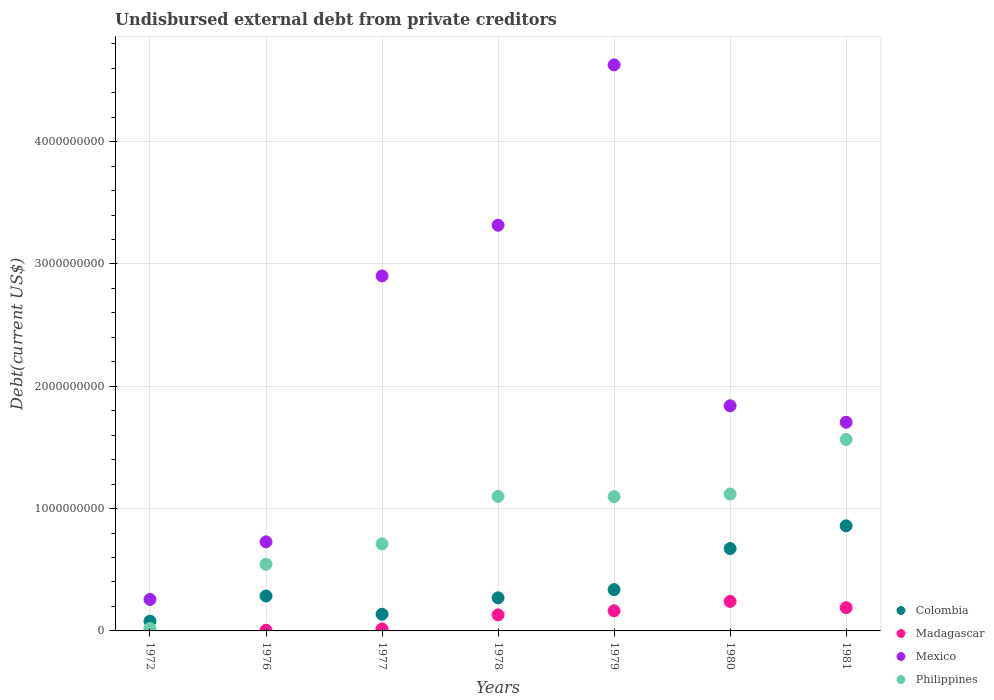What is the total debt in Colombia in 1979?
Make the answer very short. 3.38e+08. Across all years, what is the maximum total debt in Mexico?
Provide a succinct answer. 4.63e+09. Across all years, what is the minimum total debt in Colombia?
Your response must be concise. 7.95e+07. In which year was the total debt in Madagascar maximum?
Provide a short and direct response. 1980. What is the total total debt in Mexico in the graph?
Your answer should be very brief. 1.54e+1. What is the difference between the total debt in Philippines in 1972 and that in 1978?
Offer a terse response. -1.08e+09. What is the difference between the total debt in Philippines in 1978 and the total debt in Colombia in 1977?
Provide a short and direct response. 9.63e+08. What is the average total debt in Colombia per year?
Offer a very short reply. 3.77e+08. In the year 1978, what is the difference between the total debt in Madagascar and total debt in Colombia?
Give a very brief answer. -1.39e+08. In how many years, is the total debt in Mexico greater than 1600000000 US$?
Your response must be concise. 5. What is the ratio of the total debt in Madagascar in 1978 to that in 1981?
Your answer should be very brief. 0.69. Is the total debt in Philippines in 1976 less than that in 1979?
Offer a terse response. Yes. What is the difference between the highest and the second highest total debt in Mexico?
Your answer should be very brief. 1.31e+09. What is the difference between the highest and the lowest total debt in Philippines?
Offer a terse response. 1.55e+09. In how many years, is the total debt in Mexico greater than the average total debt in Mexico taken over all years?
Provide a succinct answer. 3. Is the sum of the total debt in Mexico in 1976 and 1981 greater than the maximum total debt in Colombia across all years?
Offer a very short reply. Yes. Is it the case that in every year, the sum of the total debt in Colombia and total debt in Philippines  is greater than the total debt in Madagascar?
Your answer should be very brief. Yes. Does the total debt in Mexico monotonically increase over the years?
Make the answer very short. No. Is the total debt in Mexico strictly greater than the total debt in Philippines over the years?
Provide a succinct answer. Yes. Does the graph contain grids?
Provide a succinct answer. Yes. How many legend labels are there?
Give a very brief answer. 4. How are the legend labels stacked?
Provide a succinct answer. Vertical. What is the title of the graph?
Ensure brevity in your answer.  Undisbursed external debt from private creditors. Does "St. Vincent and the Grenadines" appear as one of the legend labels in the graph?
Your response must be concise. No. What is the label or title of the X-axis?
Offer a terse response. Years. What is the label or title of the Y-axis?
Offer a terse response. Debt(current US$). What is the Debt(current US$) in Colombia in 1972?
Keep it short and to the point. 7.95e+07. What is the Debt(current US$) in Madagascar in 1972?
Make the answer very short. 1.18e+06. What is the Debt(current US$) in Mexico in 1972?
Provide a succinct answer. 2.57e+08. What is the Debt(current US$) of Philippines in 1972?
Your answer should be compact. 1.99e+07. What is the Debt(current US$) of Colombia in 1976?
Your answer should be compact. 2.85e+08. What is the Debt(current US$) in Madagascar in 1976?
Provide a short and direct response. 5.58e+06. What is the Debt(current US$) of Mexico in 1976?
Offer a very short reply. 7.28e+08. What is the Debt(current US$) of Philippines in 1976?
Offer a very short reply. 5.45e+08. What is the Debt(current US$) in Colombia in 1977?
Your answer should be very brief. 1.36e+08. What is the Debt(current US$) of Madagascar in 1977?
Your response must be concise. 1.63e+07. What is the Debt(current US$) in Mexico in 1977?
Your answer should be compact. 2.90e+09. What is the Debt(current US$) in Philippines in 1977?
Make the answer very short. 7.11e+08. What is the Debt(current US$) in Colombia in 1978?
Your response must be concise. 2.71e+08. What is the Debt(current US$) in Madagascar in 1978?
Give a very brief answer. 1.31e+08. What is the Debt(current US$) of Mexico in 1978?
Offer a terse response. 3.32e+09. What is the Debt(current US$) in Philippines in 1978?
Offer a very short reply. 1.10e+09. What is the Debt(current US$) of Colombia in 1979?
Your answer should be compact. 3.38e+08. What is the Debt(current US$) in Madagascar in 1979?
Provide a short and direct response. 1.65e+08. What is the Debt(current US$) in Mexico in 1979?
Make the answer very short. 4.63e+09. What is the Debt(current US$) in Philippines in 1979?
Your response must be concise. 1.10e+09. What is the Debt(current US$) in Colombia in 1980?
Make the answer very short. 6.73e+08. What is the Debt(current US$) in Madagascar in 1980?
Ensure brevity in your answer.  2.41e+08. What is the Debt(current US$) of Mexico in 1980?
Offer a very short reply. 1.84e+09. What is the Debt(current US$) of Philippines in 1980?
Keep it short and to the point. 1.12e+09. What is the Debt(current US$) in Colombia in 1981?
Make the answer very short. 8.59e+08. What is the Debt(current US$) in Madagascar in 1981?
Your response must be concise. 1.90e+08. What is the Debt(current US$) of Mexico in 1981?
Offer a very short reply. 1.71e+09. What is the Debt(current US$) in Philippines in 1981?
Keep it short and to the point. 1.57e+09. Across all years, what is the maximum Debt(current US$) in Colombia?
Provide a short and direct response. 8.59e+08. Across all years, what is the maximum Debt(current US$) of Madagascar?
Provide a succinct answer. 2.41e+08. Across all years, what is the maximum Debt(current US$) of Mexico?
Your answer should be compact. 4.63e+09. Across all years, what is the maximum Debt(current US$) in Philippines?
Provide a succinct answer. 1.57e+09. Across all years, what is the minimum Debt(current US$) of Colombia?
Offer a very short reply. 7.95e+07. Across all years, what is the minimum Debt(current US$) of Madagascar?
Your response must be concise. 1.18e+06. Across all years, what is the minimum Debt(current US$) in Mexico?
Give a very brief answer. 2.57e+08. Across all years, what is the minimum Debt(current US$) of Philippines?
Offer a very short reply. 1.99e+07. What is the total Debt(current US$) of Colombia in the graph?
Provide a succinct answer. 2.64e+09. What is the total Debt(current US$) of Madagascar in the graph?
Your answer should be very brief. 7.50e+08. What is the total Debt(current US$) in Mexico in the graph?
Provide a succinct answer. 1.54e+1. What is the total Debt(current US$) of Philippines in the graph?
Offer a very short reply. 6.16e+09. What is the difference between the Debt(current US$) of Colombia in 1972 and that in 1976?
Make the answer very short. -2.06e+08. What is the difference between the Debt(current US$) of Madagascar in 1972 and that in 1976?
Ensure brevity in your answer.  -4.40e+06. What is the difference between the Debt(current US$) of Mexico in 1972 and that in 1976?
Provide a succinct answer. -4.71e+08. What is the difference between the Debt(current US$) of Philippines in 1972 and that in 1976?
Your answer should be compact. -5.25e+08. What is the difference between the Debt(current US$) of Colombia in 1972 and that in 1977?
Your response must be concise. -5.70e+07. What is the difference between the Debt(current US$) of Madagascar in 1972 and that in 1977?
Make the answer very short. -1.51e+07. What is the difference between the Debt(current US$) of Mexico in 1972 and that in 1977?
Give a very brief answer. -2.65e+09. What is the difference between the Debt(current US$) in Philippines in 1972 and that in 1977?
Give a very brief answer. -6.92e+08. What is the difference between the Debt(current US$) of Colombia in 1972 and that in 1978?
Offer a terse response. -1.91e+08. What is the difference between the Debt(current US$) in Madagascar in 1972 and that in 1978?
Provide a short and direct response. -1.30e+08. What is the difference between the Debt(current US$) of Mexico in 1972 and that in 1978?
Give a very brief answer. -3.06e+09. What is the difference between the Debt(current US$) in Philippines in 1972 and that in 1978?
Your response must be concise. -1.08e+09. What is the difference between the Debt(current US$) of Colombia in 1972 and that in 1979?
Keep it short and to the point. -2.58e+08. What is the difference between the Debt(current US$) of Madagascar in 1972 and that in 1979?
Keep it short and to the point. -1.63e+08. What is the difference between the Debt(current US$) in Mexico in 1972 and that in 1979?
Provide a short and direct response. -4.37e+09. What is the difference between the Debt(current US$) in Philippines in 1972 and that in 1979?
Keep it short and to the point. -1.08e+09. What is the difference between the Debt(current US$) of Colombia in 1972 and that in 1980?
Make the answer very short. -5.94e+08. What is the difference between the Debt(current US$) of Madagascar in 1972 and that in 1980?
Provide a succinct answer. -2.40e+08. What is the difference between the Debt(current US$) of Mexico in 1972 and that in 1980?
Offer a very short reply. -1.58e+09. What is the difference between the Debt(current US$) in Philippines in 1972 and that in 1980?
Provide a succinct answer. -1.10e+09. What is the difference between the Debt(current US$) of Colombia in 1972 and that in 1981?
Keep it short and to the point. -7.80e+08. What is the difference between the Debt(current US$) of Madagascar in 1972 and that in 1981?
Give a very brief answer. -1.89e+08. What is the difference between the Debt(current US$) of Mexico in 1972 and that in 1981?
Make the answer very short. -1.45e+09. What is the difference between the Debt(current US$) in Philippines in 1972 and that in 1981?
Provide a succinct answer. -1.55e+09. What is the difference between the Debt(current US$) of Colombia in 1976 and that in 1977?
Your response must be concise. 1.49e+08. What is the difference between the Debt(current US$) of Madagascar in 1976 and that in 1977?
Provide a short and direct response. -1.07e+07. What is the difference between the Debt(current US$) of Mexico in 1976 and that in 1977?
Offer a terse response. -2.17e+09. What is the difference between the Debt(current US$) of Philippines in 1976 and that in 1977?
Offer a terse response. -1.66e+08. What is the difference between the Debt(current US$) in Colombia in 1976 and that in 1978?
Offer a terse response. 1.49e+07. What is the difference between the Debt(current US$) in Madagascar in 1976 and that in 1978?
Give a very brief answer. -1.26e+08. What is the difference between the Debt(current US$) of Mexico in 1976 and that in 1978?
Your answer should be very brief. -2.59e+09. What is the difference between the Debt(current US$) of Philippines in 1976 and that in 1978?
Ensure brevity in your answer.  -5.54e+08. What is the difference between the Debt(current US$) in Colombia in 1976 and that in 1979?
Make the answer very short. -5.21e+07. What is the difference between the Debt(current US$) in Madagascar in 1976 and that in 1979?
Ensure brevity in your answer.  -1.59e+08. What is the difference between the Debt(current US$) in Mexico in 1976 and that in 1979?
Provide a succinct answer. -3.90e+09. What is the difference between the Debt(current US$) in Philippines in 1976 and that in 1979?
Make the answer very short. -5.53e+08. What is the difference between the Debt(current US$) of Colombia in 1976 and that in 1980?
Provide a short and direct response. -3.88e+08. What is the difference between the Debt(current US$) of Madagascar in 1976 and that in 1980?
Your response must be concise. -2.36e+08. What is the difference between the Debt(current US$) of Mexico in 1976 and that in 1980?
Ensure brevity in your answer.  -1.11e+09. What is the difference between the Debt(current US$) in Philippines in 1976 and that in 1980?
Your answer should be compact. -5.74e+08. What is the difference between the Debt(current US$) of Colombia in 1976 and that in 1981?
Give a very brief answer. -5.74e+08. What is the difference between the Debt(current US$) in Madagascar in 1976 and that in 1981?
Provide a short and direct response. -1.84e+08. What is the difference between the Debt(current US$) in Mexico in 1976 and that in 1981?
Ensure brevity in your answer.  -9.77e+08. What is the difference between the Debt(current US$) in Philippines in 1976 and that in 1981?
Provide a succinct answer. -1.02e+09. What is the difference between the Debt(current US$) of Colombia in 1977 and that in 1978?
Give a very brief answer. -1.34e+08. What is the difference between the Debt(current US$) of Madagascar in 1977 and that in 1978?
Provide a succinct answer. -1.15e+08. What is the difference between the Debt(current US$) in Mexico in 1977 and that in 1978?
Your answer should be compact. -4.14e+08. What is the difference between the Debt(current US$) in Philippines in 1977 and that in 1978?
Offer a very short reply. -3.88e+08. What is the difference between the Debt(current US$) of Colombia in 1977 and that in 1979?
Give a very brief answer. -2.01e+08. What is the difference between the Debt(current US$) of Madagascar in 1977 and that in 1979?
Provide a succinct answer. -1.48e+08. What is the difference between the Debt(current US$) of Mexico in 1977 and that in 1979?
Keep it short and to the point. -1.73e+09. What is the difference between the Debt(current US$) in Philippines in 1977 and that in 1979?
Your response must be concise. -3.86e+08. What is the difference between the Debt(current US$) of Colombia in 1977 and that in 1980?
Your answer should be compact. -5.37e+08. What is the difference between the Debt(current US$) in Madagascar in 1977 and that in 1980?
Offer a terse response. -2.25e+08. What is the difference between the Debt(current US$) in Mexico in 1977 and that in 1980?
Keep it short and to the point. 1.06e+09. What is the difference between the Debt(current US$) in Philippines in 1977 and that in 1980?
Offer a very short reply. -4.08e+08. What is the difference between the Debt(current US$) of Colombia in 1977 and that in 1981?
Offer a very short reply. -7.23e+08. What is the difference between the Debt(current US$) in Madagascar in 1977 and that in 1981?
Give a very brief answer. -1.74e+08. What is the difference between the Debt(current US$) in Mexico in 1977 and that in 1981?
Make the answer very short. 1.20e+09. What is the difference between the Debt(current US$) of Philippines in 1977 and that in 1981?
Provide a short and direct response. -8.54e+08. What is the difference between the Debt(current US$) of Colombia in 1978 and that in 1979?
Offer a terse response. -6.69e+07. What is the difference between the Debt(current US$) in Madagascar in 1978 and that in 1979?
Provide a succinct answer. -3.35e+07. What is the difference between the Debt(current US$) in Mexico in 1978 and that in 1979?
Give a very brief answer. -1.31e+09. What is the difference between the Debt(current US$) in Philippines in 1978 and that in 1979?
Keep it short and to the point. 1.78e+06. What is the difference between the Debt(current US$) of Colombia in 1978 and that in 1980?
Your answer should be compact. -4.03e+08. What is the difference between the Debt(current US$) in Madagascar in 1978 and that in 1980?
Offer a terse response. -1.10e+08. What is the difference between the Debt(current US$) in Mexico in 1978 and that in 1980?
Your response must be concise. 1.48e+09. What is the difference between the Debt(current US$) in Philippines in 1978 and that in 1980?
Ensure brevity in your answer.  -1.93e+07. What is the difference between the Debt(current US$) in Colombia in 1978 and that in 1981?
Offer a very short reply. -5.89e+08. What is the difference between the Debt(current US$) in Madagascar in 1978 and that in 1981?
Provide a short and direct response. -5.89e+07. What is the difference between the Debt(current US$) of Mexico in 1978 and that in 1981?
Offer a terse response. 1.61e+09. What is the difference between the Debt(current US$) in Philippines in 1978 and that in 1981?
Your response must be concise. -4.66e+08. What is the difference between the Debt(current US$) of Colombia in 1979 and that in 1980?
Your answer should be very brief. -3.36e+08. What is the difference between the Debt(current US$) in Madagascar in 1979 and that in 1980?
Give a very brief answer. -7.65e+07. What is the difference between the Debt(current US$) in Mexico in 1979 and that in 1980?
Keep it short and to the point. 2.79e+09. What is the difference between the Debt(current US$) in Philippines in 1979 and that in 1980?
Make the answer very short. -2.11e+07. What is the difference between the Debt(current US$) of Colombia in 1979 and that in 1981?
Make the answer very short. -5.22e+08. What is the difference between the Debt(current US$) of Madagascar in 1979 and that in 1981?
Provide a short and direct response. -2.54e+07. What is the difference between the Debt(current US$) of Mexico in 1979 and that in 1981?
Your response must be concise. 2.92e+09. What is the difference between the Debt(current US$) of Philippines in 1979 and that in 1981?
Your response must be concise. -4.67e+08. What is the difference between the Debt(current US$) in Colombia in 1980 and that in 1981?
Ensure brevity in your answer.  -1.86e+08. What is the difference between the Debt(current US$) in Madagascar in 1980 and that in 1981?
Give a very brief answer. 5.11e+07. What is the difference between the Debt(current US$) of Mexico in 1980 and that in 1981?
Offer a very short reply. 1.35e+08. What is the difference between the Debt(current US$) of Philippines in 1980 and that in 1981?
Provide a succinct answer. -4.46e+08. What is the difference between the Debt(current US$) in Colombia in 1972 and the Debt(current US$) in Madagascar in 1976?
Make the answer very short. 7.39e+07. What is the difference between the Debt(current US$) of Colombia in 1972 and the Debt(current US$) of Mexico in 1976?
Offer a very short reply. -6.49e+08. What is the difference between the Debt(current US$) of Colombia in 1972 and the Debt(current US$) of Philippines in 1976?
Offer a terse response. -4.66e+08. What is the difference between the Debt(current US$) of Madagascar in 1972 and the Debt(current US$) of Mexico in 1976?
Make the answer very short. -7.27e+08. What is the difference between the Debt(current US$) of Madagascar in 1972 and the Debt(current US$) of Philippines in 1976?
Keep it short and to the point. -5.44e+08. What is the difference between the Debt(current US$) in Mexico in 1972 and the Debt(current US$) in Philippines in 1976?
Ensure brevity in your answer.  -2.88e+08. What is the difference between the Debt(current US$) of Colombia in 1972 and the Debt(current US$) of Madagascar in 1977?
Your response must be concise. 6.32e+07. What is the difference between the Debt(current US$) in Colombia in 1972 and the Debt(current US$) in Mexico in 1977?
Ensure brevity in your answer.  -2.82e+09. What is the difference between the Debt(current US$) in Colombia in 1972 and the Debt(current US$) in Philippines in 1977?
Provide a succinct answer. -6.32e+08. What is the difference between the Debt(current US$) in Madagascar in 1972 and the Debt(current US$) in Mexico in 1977?
Provide a short and direct response. -2.90e+09. What is the difference between the Debt(current US$) of Madagascar in 1972 and the Debt(current US$) of Philippines in 1977?
Keep it short and to the point. -7.10e+08. What is the difference between the Debt(current US$) in Mexico in 1972 and the Debt(current US$) in Philippines in 1977?
Ensure brevity in your answer.  -4.54e+08. What is the difference between the Debt(current US$) in Colombia in 1972 and the Debt(current US$) in Madagascar in 1978?
Provide a short and direct response. -5.17e+07. What is the difference between the Debt(current US$) of Colombia in 1972 and the Debt(current US$) of Mexico in 1978?
Give a very brief answer. -3.24e+09. What is the difference between the Debt(current US$) in Colombia in 1972 and the Debt(current US$) in Philippines in 1978?
Offer a terse response. -1.02e+09. What is the difference between the Debt(current US$) of Madagascar in 1972 and the Debt(current US$) of Mexico in 1978?
Offer a terse response. -3.32e+09. What is the difference between the Debt(current US$) of Madagascar in 1972 and the Debt(current US$) of Philippines in 1978?
Your answer should be very brief. -1.10e+09. What is the difference between the Debt(current US$) of Mexico in 1972 and the Debt(current US$) of Philippines in 1978?
Keep it short and to the point. -8.42e+08. What is the difference between the Debt(current US$) in Colombia in 1972 and the Debt(current US$) in Madagascar in 1979?
Offer a terse response. -8.52e+07. What is the difference between the Debt(current US$) of Colombia in 1972 and the Debt(current US$) of Mexico in 1979?
Ensure brevity in your answer.  -4.55e+09. What is the difference between the Debt(current US$) in Colombia in 1972 and the Debt(current US$) in Philippines in 1979?
Your response must be concise. -1.02e+09. What is the difference between the Debt(current US$) in Madagascar in 1972 and the Debt(current US$) in Mexico in 1979?
Make the answer very short. -4.63e+09. What is the difference between the Debt(current US$) in Madagascar in 1972 and the Debt(current US$) in Philippines in 1979?
Make the answer very short. -1.10e+09. What is the difference between the Debt(current US$) in Mexico in 1972 and the Debt(current US$) in Philippines in 1979?
Ensure brevity in your answer.  -8.41e+08. What is the difference between the Debt(current US$) in Colombia in 1972 and the Debt(current US$) in Madagascar in 1980?
Offer a terse response. -1.62e+08. What is the difference between the Debt(current US$) in Colombia in 1972 and the Debt(current US$) in Mexico in 1980?
Make the answer very short. -1.76e+09. What is the difference between the Debt(current US$) in Colombia in 1972 and the Debt(current US$) in Philippines in 1980?
Your answer should be compact. -1.04e+09. What is the difference between the Debt(current US$) in Madagascar in 1972 and the Debt(current US$) in Mexico in 1980?
Make the answer very short. -1.84e+09. What is the difference between the Debt(current US$) of Madagascar in 1972 and the Debt(current US$) of Philippines in 1980?
Ensure brevity in your answer.  -1.12e+09. What is the difference between the Debt(current US$) in Mexico in 1972 and the Debt(current US$) in Philippines in 1980?
Offer a terse response. -8.62e+08. What is the difference between the Debt(current US$) in Colombia in 1972 and the Debt(current US$) in Madagascar in 1981?
Provide a short and direct response. -1.11e+08. What is the difference between the Debt(current US$) in Colombia in 1972 and the Debt(current US$) in Mexico in 1981?
Your answer should be very brief. -1.63e+09. What is the difference between the Debt(current US$) in Colombia in 1972 and the Debt(current US$) in Philippines in 1981?
Your answer should be very brief. -1.49e+09. What is the difference between the Debt(current US$) of Madagascar in 1972 and the Debt(current US$) of Mexico in 1981?
Offer a very short reply. -1.70e+09. What is the difference between the Debt(current US$) in Madagascar in 1972 and the Debt(current US$) in Philippines in 1981?
Offer a very short reply. -1.56e+09. What is the difference between the Debt(current US$) of Mexico in 1972 and the Debt(current US$) of Philippines in 1981?
Provide a succinct answer. -1.31e+09. What is the difference between the Debt(current US$) of Colombia in 1976 and the Debt(current US$) of Madagascar in 1977?
Make the answer very short. 2.69e+08. What is the difference between the Debt(current US$) of Colombia in 1976 and the Debt(current US$) of Mexico in 1977?
Offer a very short reply. -2.62e+09. What is the difference between the Debt(current US$) in Colombia in 1976 and the Debt(current US$) in Philippines in 1977?
Keep it short and to the point. -4.26e+08. What is the difference between the Debt(current US$) of Madagascar in 1976 and the Debt(current US$) of Mexico in 1977?
Make the answer very short. -2.90e+09. What is the difference between the Debt(current US$) of Madagascar in 1976 and the Debt(current US$) of Philippines in 1977?
Keep it short and to the point. -7.06e+08. What is the difference between the Debt(current US$) of Mexico in 1976 and the Debt(current US$) of Philippines in 1977?
Keep it short and to the point. 1.70e+07. What is the difference between the Debt(current US$) of Colombia in 1976 and the Debt(current US$) of Madagascar in 1978?
Make the answer very short. 1.54e+08. What is the difference between the Debt(current US$) of Colombia in 1976 and the Debt(current US$) of Mexico in 1978?
Offer a terse response. -3.03e+09. What is the difference between the Debt(current US$) in Colombia in 1976 and the Debt(current US$) in Philippines in 1978?
Give a very brief answer. -8.14e+08. What is the difference between the Debt(current US$) in Madagascar in 1976 and the Debt(current US$) in Mexico in 1978?
Provide a short and direct response. -3.31e+09. What is the difference between the Debt(current US$) of Madagascar in 1976 and the Debt(current US$) of Philippines in 1978?
Your answer should be very brief. -1.09e+09. What is the difference between the Debt(current US$) in Mexico in 1976 and the Debt(current US$) in Philippines in 1978?
Your answer should be compact. -3.71e+08. What is the difference between the Debt(current US$) in Colombia in 1976 and the Debt(current US$) in Madagascar in 1979?
Offer a terse response. 1.21e+08. What is the difference between the Debt(current US$) of Colombia in 1976 and the Debt(current US$) of Mexico in 1979?
Give a very brief answer. -4.34e+09. What is the difference between the Debt(current US$) of Colombia in 1976 and the Debt(current US$) of Philippines in 1979?
Your answer should be very brief. -8.12e+08. What is the difference between the Debt(current US$) in Madagascar in 1976 and the Debt(current US$) in Mexico in 1979?
Provide a short and direct response. -4.62e+09. What is the difference between the Debt(current US$) in Madagascar in 1976 and the Debt(current US$) in Philippines in 1979?
Give a very brief answer. -1.09e+09. What is the difference between the Debt(current US$) of Mexico in 1976 and the Debt(current US$) of Philippines in 1979?
Provide a short and direct response. -3.69e+08. What is the difference between the Debt(current US$) in Colombia in 1976 and the Debt(current US$) in Madagascar in 1980?
Your answer should be compact. 4.43e+07. What is the difference between the Debt(current US$) of Colombia in 1976 and the Debt(current US$) of Mexico in 1980?
Offer a terse response. -1.56e+09. What is the difference between the Debt(current US$) in Colombia in 1976 and the Debt(current US$) in Philippines in 1980?
Provide a succinct answer. -8.34e+08. What is the difference between the Debt(current US$) in Madagascar in 1976 and the Debt(current US$) in Mexico in 1980?
Your response must be concise. -1.84e+09. What is the difference between the Debt(current US$) in Madagascar in 1976 and the Debt(current US$) in Philippines in 1980?
Your answer should be very brief. -1.11e+09. What is the difference between the Debt(current US$) of Mexico in 1976 and the Debt(current US$) of Philippines in 1980?
Offer a very short reply. -3.91e+08. What is the difference between the Debt(current US$) of Colombia in 1976 and the Debt(current US$) of Madagascar in 1981?
Make the answer very short. 9.54e+07. What is the difference between the Debt(current US$) of Colombia in 1976 and the Debt(current US$) of Mexico in 1981?
Offer a terse response. -1.42e+09. What is the difference between the Debt(current US$) of Colombia in 1976 and the Debt(current US$) of Philippines in 1981?
Offer a very short reply. -1.28e+09. What is the difference between the Debt(current US$) in Madagascar in 1976 and the Debt(current US$) in Mexico in 1981?
Your answer should be very brief. -1.70e+09. What is the difference between the Debt(current US$) of Madagascar in 1976 and the Debt(current US$) of Philippines in 1981?
Ensure brevity in your answer.  -1.56e+09. What is the difference between the Debt(current US$) in Mexico in 1976 and the Debt(current US$) in Philippines in 1981?
Provide a succinct answer. -8.37e+08. What is the difference between the Debt(current US$) of Colombia in 1977 and the Debt(current US$) of Madagascar in 1978?
Give a very brief answer. 5.23e+06. What is the difference between the Debt(current US$) of Colombia in 1977 and the Debt(current US$) of Mexico in 1978?
Make the answer very short. -3.18e+09. What is the difference between the Debt(current US$) of Colombia in 1977 and the Debt(current US$) of Philippines in 1978?
Keep it short and to the point. -9.63e+08. What is the difference between the Debt(current US$) of Madagascar in 1977 and the Debt(current US$) of Mexico in 1978?
Offer a very short reply. -3.30e+09. What is the difference between the Debt(current US$) of Madagascar in 1977 and the Debt(current US$) of Philippines in 1978?
Your answer should be compact. -1.08e+09. What is the difference between the Debt(current US$) in Mexico in 1977 and the Debt(current US$) in Philippines in 1978?
Offer a very short reply. 1.80e+09. What is the difference between the Debt(current US$) in Colombia in 1977 and the Debt(current US$) in Madagascar in 1979?
Give a very brief answer. -2.83e+07. What is the difference between the Debt(current US$) in Colombia in 1977 and the Debt(current US$) in Mexico in 1979?
Offer a terse response. -4.49e+09. What is the difference between the Debt(current US$) in Colombia in 1977 and the Debt(current US$) in Philippines in 1979?
Provide a succinct answer. -9.61e+08. What is the difference between the Debt(current US$) of Madagascar in 1977 and the Debt(current US$) of Mexico in 1979?
Make the answer very short. -4.61e+09. What is the difference between the Debt(current US$) in Madagascar in 1977 and the Debt(current US$) in Philippines in 1979?
Provide a short and direct response. -1.08e+09. What is the difference between the Debt(current US$) in Mexico in 1977 and the Debt(current US$) in Philippines in 1979?
Make the answer very short. 1.80e+09. What is the difference between the Debt(current US$) in Colombia in 1977 and the Debt(current US$) in Madagascar in 1980?
Keep it short and to the point. -1.05e+08. What is the difference between the Debt(current US$) in Colombia in 1977 and the Debt(current US$) in Mexico in 1980?
Provide a short and direct response. -1.70e+09. What is the difference between the Debt(current US$) in Colombia in 1977 and the Debt(current US$) in Philippines in 1980?
Offer a very short reply. -9.83e+08. What is the difference between the Debt(current US$) in Madagascar in 1977 and the Debt(current US$) in Mexico in 1980?
Give a very brief answer. -1.82e+09. What is the difference between the Debt(current US$) of Madagascar in 1977 and the Debt(current US$) of Philippines in 1980?
Offer a very short reply. -1.10e+09. What is the difference between the Debt(current US$) in Mexico in 1977 and the Debt(current US$) in Philippines in 1980?
Offer a terse response. 1.78e+09. What is the difference between the Debt(current US$) of Colombia in 1977 and the Debt(current US$) of Madagascar in 1981?
Ensure brevity in your answer.  -5.37e+07. What is the difference between the Debt(current US$) of Colombia in 1977 and the Debt(current US$) of Mexico in 1981?
Provide a short and direct response. -1.57e+09. What is the difference between the Debt(current US$) of Colombia in 1977 and the Debt(current US$) of Philippines in 1981?
Make the answer very short. -1.43e+09. What is the difference between the Debt(current US$) of Madagascar in 1977 and the Debt(current US$) of Mexico in 1981?
Ensure brevity in your answer.  -1.69e+09. What is the difference between the Debt(current US$) in Madagascar in 1977 and the Debt(current US$) in Philippines in 1981?
Give a very brief answer. -1.55e+09. What is the difference between the Debt(current US$) of Mexico in 1977 and the Debt(current US$) of Philippines in 1981?
Keep it short and to the point. 1.34e+09. What is the difference between the Debt(current US$) in Colombia in 1978 and the Debt(current US$) in Madagascar in 1979?
Make the answer very short. 1.06e+08. What is the difference between the Debt(current US$) of Colombia in 1978 and the Debt(current US$) of Mexico in 1979?
Keep it short and to the point. -4.36e+09. What is the difference between the Debt(current US$) in Colombia in 1978 and the Debt(current US$) in Philippines in 1979?
Keep it short and to the point. -8.27e+08. What is the difference between the Debt(current US$) of Madagascar in 1978 and the Debt(current US$) of Mexico in 1979?
Provide a short and direct response. -4.50e+09. What is the difference between the Debt(current US$) of Madagascar in 1978 and the Debt(current US$) of Philippines in 1979?
Provide a short and direct response. -9.67e+08. What is the difference between the Debt(current US$) of Mexico in 1978 and the Debt(current US$) of Philippines in 1979?
Your answer should be very brief. 2.22e+09. What is the difference between the Debt(current US$) of Colombia in 1978 and the Debt(current US$) of Madagascar in 1980?
Ensure brevity in your answer.  2.94e+07. What is the difference between the Debt(current US$) in Colombia in 1978 and the Debt(current US$) in Mexico in 1980?
Offer a very short reply. -1.57e+09. What is the difference between the Debt(current US$) in Colombia in 1978 and the Debt(current US$) in Philippines in 1980?
Give a very brief answer. -8.48e+08. What is the difference between the Debt(current US$) in Madagascar in 1978 and the Debt(current US$) in Mexico in 1980?
Make the answer very short. -1.71e+09. What is the difference between the Debt(current US$) in Madagascar in 1978 and the Debt(current US$) in Philippines in 1980?
Provide a short and direct response. -9.88e+08. What is the difference between the Debt(current US$) of Mexico in 1978 and the Debt(current US$) of Philippines in 1980?
Provide a succinct answer. 2.20e+09. What is the difference between the Debt(current US$) in Colombia in 1978 and the Debt(current US$) in Madagascar in 1981?
Your answer should be compact. 8.05e+07. What is the difference between the Debt(current US$) of Colombia in 1978 and the Debt(current US$) of Mexico in 1981?
Your answer should be very brief. -1.44e+09. What is the difference between the Debt(current US$) in Colombia in 1978 and the Debt(current US$) in Philippines in 1981?
Your answer should be compact. -1.29e+09. What is the difference between the Debt(current US$) in Madagascar in 1978 and the Debt(current US$) in Mexico in 1981?
Keep it short and to the point. -1.57e+09. What is the difference between the Debt(current US$) of Madagascar in 1978 and the Debt(current US$) of Philippines in 1981?
Your response must be concise. -1.43e+09. What is the difference between the Debt(current US$) in Mexico in 1978 and the Debt(current US$) in Philippines in 1981?
Provide a succinct answer. 1.75e+09. What is the difference between the Debt(current US$) in Colombia in 1979 and the Debt(current US$) in Madagascar in 1980?
Give a very brief answer. 9.64e+07. What is the difference between the Debt(current US$) in Colombia in 1979 and the Debt(current US$) in Mexico in 1980?
Keep it short and to the point. -1.50e+09. What is the difference between the Debt(current US$) of Colombia in 1979 and the Debt(current US$) of Philippines in 1980?
Give a very brief answer. -7.81e+08. What is the difference between the Debt(current US$) of Madagascar in 1979 and the Debt(current US$) of Mexico in 1980?
Your answer should be very brief. -1.68e+09. What is the difference between the Debt(current US$) in Madagascar in 1979 and the Debt(current US$) in Philippines in 1980?
Ensure brevity in your answer.  -9.54e+08. What is the difference between the Debt(current US$) of Mexico in 1979 and the Debt(current US$) of Philippines in 1980?
Your answer should be compact. 3.51e+09. What is the difference between the Debt(current US$) in Colombia in 1979 and the Debt(current US$) in Madagascar in 1981?
Your response must be concise. 1.47e+08. What is the difference between the Debt(current US$) of Colombia in 1979 and the Debt(current US$) of Mexico in 1981?
Ensure brevity in your answer.  -1.37e+09. What is the difference between the Debt(current US$) of Colombia in 1979 and the Debt(current US$) of Philippines in 1981?
Give a very brief answer. -1.23e+09. What is the difference between the Debt(current US$) in Madagascar in 1979 and the Debt(current US$) in Mexico in 1981?
Give a very brief answer. -1.54e+09. What is the difference between the Debt(current US$) of Madagascar in 1979 and the Debt(current US$) of Philippines in 1981?
Offer a very short reply. -1.40e+09. What is the difference between the Debt(current US$) of Mexico in 1979 and the Debt(current US$) of Philippines in 1981?
Your answer should be compact. 3.06e+09. What is the difference between the Debt(current US$) of Colombia in 1980 and the Debt(current US$) of Madagascar in 1981?
Your response must be concise. 4.83e+08. What is the difference between the Debt(current US$) in Colombia in 1980 and the Debt(current US$) in Mexico in 1981?
Your answer should be very brief. -1.03e+09. What is the difference between the Debt(current US$) in Colombia in 1980 and the Debt(current US$) in Philippines in 1981?
Make the answer very short. -8.92e+08. What is the difference between the Debt(current US$) in Madagascar in 1980 and the Debt(current US$) in Mexico in 1981?
Offer a very short reply. -1.46e+09. What is the difference between the Debt(current US$) in Madagascar in 1980 and the Debt(current US$) in Philippines in 1981?
Your answer should be compact. -1.32e+09. What is the difference between the Debt(current US$) of Mexico in 1980 and the Debt(current US$) of Philippines in 1981?
Provide a short and direct response. 2.76e+08. What is the average Debt(current US$) of Colombia per year?
Give a very brief answer. 3.77e+08. What is the average Debt(current US$) in Madagascar per year?
Offer a terse response. 1.07e+08. What is the average Debt(current US$) in Mexico per year?
Provide a succinct answer. 2.20e+09. What is the average Debt(current US$) of Philippines per year?
Offer a very short reply. 8.80e+08. In the year 1972, what is the difference between the Debt(current US$) of Colombia and Debt(current US$) of Madagascar?
Your answer should be very brief. 7.83e+07. In the year 1972, what is the difference between the Debt(current US$) of Colombia and Debt(current US$) of Mexico?
Ensure brevity in your answer.  -1.78e+08. In the year 1972, what is the difference between the Debt(current US$) of Colombia and Debt(current US$) of Philippines?
Your response must be concise. 5.96e+07. In the year 1972, what is the difference between the Debt(current US$) in Madagascar and Debt(current US$) in Mexico?
Offer a terse response. -2.56e+08. In the year 1972, what is the difference between the Debt(current US$) in Madagascar and Debt(current US$) in Philippines?
Keep it short and to the point. -1.87e+07. In the year 1972, what is the difference between the Debt(current US$) of Mexico and Debt(current US$) of Philippines?
Ensure brevity in your answer.  2.37e+08. In the year 1976, what is the difference between the Debt(current US$) of Colombia and Debt(current US$) of Madagascar?
Make the answer very short. 2.80e+08. In the year 1976, what is the difference between the Debt(current US$) of Colombia and Debt(current US$) of Mexico?
Provide a succinct answer. -4.43e+08. In the year 1976, what is the difference between the Debt(current US$) of Colombia and Debt(current US$) of Philippines?
Your answer should be very brief. -2.60e+08. In the year 1976, what is the difference between the Debt(current US$) in Madagascar and Debt(current US$) in Mexico?
Give a very brief answer. -7.23e+08. In the year 1976, what is the difference between the Debt(current US$) in Madagascar and Debt(current US$) in Philippines?
Provide a short and direct response. -5.40e+08. In the year 1976, what is the difference between the Debt(current US$) of Mexico and Debt(current US$) of Philippines?
Your response must be concise. 1.83e+08. In the year 1977, what is the difference between the Debt(current US$) of Colombia and Debt(current US$) of Madagascar?
Ensure brevity in your answer.  1.20e+08. In the year 1977, what is the difference between the Debt(current US$) in Colombia and Debt(current US$) in Mexico?
Your answer should be very brief. -2.77e+09. In the year 1977, what is the difference between the Debt(current US$) of Colombia and Debt(current US$) of Philippines?
Offer a very short reply. -5.75e+08. In the year 1977, what is the difference between the Debt(current US$) of Madagascar and Debt(current US$) of Mexico?
Offer a very short reply. -2.89e+09. In the year 1977, what is the difference between the Debt(current US$) of Madagascar and Debt(current US$) of Philippines?
Your answer should be very brief. -6.95e+08. In the year 1977, what is the difference between the Debt(current US$) of Mexico and Debt(current US$) of Philippines?
Provide a short and direct response. 2.19e+09. In the year 1978, what is the difference between the Debt(current US$) in Colombia and Debt(current US$) in Madagascar?
Keep it short and to the point. 1.39e+08. In the year 1978, what is the difference between the Debt(current US$) in Colombia and Debt(current US$) in Mexico?
Your answer should be very brief. -3.05e+09. In the year 1978, what is the difference between the Debt(current US$) of Colombia and Debt(current US$) of Philippines?
Provide a short and direct response. -8.29e+08. In the year 1978, what is the difference between the Debt(current US$) in Madagascar and Debt(current US$) in Mexico?
Your answer should be compact. -3.19e+09. In the year 1978, what is the difference between the Debt(current US$) in Madagascar and Debt(current US$) in Philippines?
Your answer should be compact. -9.68e+08. In the year 1978, what is the difference between the Debt(current US$) of Mexico and Debt(current US$) of Philippines?
Offer a terse response. 2.22e+09. In the year 1979, what is the difference between the Debt(current US$) of Colombia and Debt(current US$) of Madagascar?
Ensure brevity in your answer.  1.73e+08. In the year 1979, what is the difference between the Debt(current US$) of Colombia and Debt(current US$) of Mexico?
Make the answer very short. -4.29e+09. In the year 1979, what is the difference between the Debt(current US$) in Colombia and Debt(current US$) in Philippines?
Provide a succinct answer. -7.60e+08. In the year 1979, what is the difference between the Debt(current US$) in Madagascar and Debt(current US$) in Mexico?
Your response must be concise. -4.46e+09. In the year 1979, what is the difference between the Debt(current US$) of Madagascar and Debt(current US$) of Philippines?
Your answer should be compact. -9.33e+08. In the year 1979, what is the difference between the Debt(current US$) of Mexico and Debt(current US$) of Philippines?
Provide a succinct answer. 3.53e+09. In the year 1980, what is the difference between the Debt(current US$) in Colombia and Debt(current US$) in Madagascar?
Your response must be concise. 4.32e+08. In the year 1980, what is the difference between the Debt(current US$) of Colombia and Debt(current US$) of Mexico?
Make the answer very short. -1.17e+09. In the year 1980, what is the difference between the Debt(current US$) of Colombia and Debt(current US$) of Philippines?
Your response must be concise. -4.46e+08. In the year 1980, what is the difference between the Debt(current US$) in Madagascar and Debt(current US$) in Mexico?
Make the answer very short. -1.60e+09. In the year 1980, what is the difference between the Debt(current US$) in Madagascar and Debt(current US$) in Philippines?
Your answer should be compact. -8.78e+08. In the year 1980, what is the difference between the Debt(current US$) of Mexico and Debt(current US$) of Philippines?
Provide a short and direct response. 7.22e+08. In the year 1981, what is the difference between the Debt(current US$) of Colombia and Debt(current US$) of Madagascar?
Your response must be concise. 6.69e+08. In the year 1981, what is the difference between the Debt(current US$) of Colombia and Debt(current US$) of Mexico?
Give a very brief answer. -8.46e+08. In the year 1981, what is the difference between the Debt(current US$) of Colombia and Debt(current US$) of Philippines?
Your answer should be very brief. -7.06e+08. In the year 1981, what is the difference between the Debt(current US$) in Madagascar and Debt(current US$) in Mexico?
Keep it short and to the point. -1.52e+09. In the year 1981, what is the difference between the Debt(current US$) in Madagascar and Debt(current US$) in Philippines?
Ensure brevity in your answer.  -1.38e+09. In the year 1981, what is the difference between the Debt(current US$) in Mexico and Debt(current US$) in Philippines?
Ensure brevity in your answer.  1.41e+08. What is the ratio of the Debt(current US$) of Colombia in 1972 to that in 1976?
Offer a very short reply. 0.28. What is the ratio of the Debt(current US$) in Madagascar in 1972 to that in 1976?
Make the answer very short. 0.21. What is the ratio of the Debt(current US$) of Mexico in 1972 to that in 1976?
Keep it short and to the point. 0.35. What is the ratio of the Debt(current US$) in Philippines in 1972 to that in 1976?
Ensure brevity in your answer.  0.04. What is the ratio of the Debt(current US$) of Colombia in 1972 to that in 1977?
Your response must be concise. 0.58. What is the ratio of the Debt(current US$) in Madagascar in 1972 to that in 1977?
Your response must be concise. 0.07. What is the ratio of the Debt(current US$) of Mexico in 1972 to that in 1977?
Provide a short and direct response. 0.09. What is the ratio of the Debt(current US$) of Philippines in 1972 to that in 1977?
Give a very brief answer. 0.03. What is the ratio of the Debt(current US$) in Colombia in 1972 to that in 1978?
Make the answer very short. 0.29. What is the ratio of the Debt(current US$) of Madagascar in 1972 to that in 1978?
Provide a short and direct response. 0.01. What is the ratio of the Debt(current US$) in Mexico in 1972 to that in 1978?
Offer a terse response. 0.08. What is the ratio of the Debt(current US$) of Philippines in 1972 to that in 1978?
Provide a succinct answer. 0.02. What is the ratio of the Debt(current US$) of Colombia in 1972 to that in 1979?
Your answer should be compact. 0.24. What is the ratio of the Debt(current US$) in Madagascar in 1972 to that in 1979?
Offer a terse response. 0.01. What is the ratio of the Debt(current US$) in Mexico in 1972 to that in 1979?
Provide a succinct answer. 0.06. What is the ratio of the Debt(current US$) of Philippines in 1972 to that in 1979?
Keep it short and to the point. 0.02. What is the ratio of the Debt(current US$) in Colombia in 1972 to that in 1980?
Keep it short and to the point. 0.12. What is the ratio of the Debt(current US$) of Madagascar in 1972 to that in 1980?
Offer a terse response. 0. What is the ratio of the Debt(current US$) of Mexico in 1972 to that in 1980?
Offer a terse response. 0.14. What is the ratio of the Debt(current US$) in Philippines in 1972 to that in 1980?
Your answer should be compact. 0.02. What is the ratio of the Debt(current US$) of Colombia in 1972 to that in 1981?
Your answer should be compact. 0.09. What is the ratio of the Debt(current US$) of Madagascar in 1972 to that in 1981?
Offer a terse response. 0.01. What is the ratio of the Debt(current US$) in Mexico in 1972 to that in 1981?
Your answer should be compact. 0.15. What is the ratio of the Debt(current US$) of Philippines in 1972 to that in 1981?
Offer a terse response. 0.01. What is the ratio of the Debt(current US$) in Colombia in 1976 to that in 1977?
Offer a very short reply. 2.09. What is the ratio of the Debt(current US$) in Madagascar in 1976 to that in 1977?
Offer a terse response. 0.34. What is the ratio of the Debt(current US$) in Mexico in 1976 to that in 1977?
Provide a succinct answer. 0.25. What is the ratio of the Debt(current US$) in Philippines in 1976 to that in 1977?
Offer a very short reply. 0.77. What is the ratio of the Debt(current US$) in Colombia in 1976 to that in 1978?
Offer a very short reply. 1.05. What is the ratio of the Debt(current US$) in Madagascar in 1976 to that in 1978?
Your response must be concise. 0.04. What is the ratio of the Debt(current US$) of Mexico in 1976 to that in 1978?
Offer a very short reply. 0.22. What is the ratio of the Debt(current US$) in Philippines in 1976 to that in 1978?
Make the answer very short. 0.5. What is the ratio of the Debt(current US$) of Colombia in 1976 to that in 1979?
Provide a succinct answer. 0.85. What is the ratio of the Debt(current US$) of Madagascar in 1976 to that in 1979?
Give a very brief answer. 0.03. What is the ratio of the Debt(current US$) of Mexico in 1976 to that in 1979?
Give a very brief answer. 0.16. What is the ratio of the Debt(current US$) of Philippines in 1976 to that in 1979?
Your answer should be compact. 0.5. What is the ratio of the Debt(current US$) of Colombia in 1976 to that in 1980?
Your answer should be compact. 0.42. What is the ratio of the Debt(current US$) in Madagascar in 1976 to that in 1980?
Your response must be concise. 0.02. What is the ratio of the Debt(current US$) of Mexico in 1976 to that in 1980?
Make the answer very short. 0.4. What is the ratio of the Debt(current US$) in Philippines in 1976 to that in 1980?
Provide a short and direct response. 0.49. What is the ratio of the Debt(current US$) in Colombia in 1976 to that in 1981?
Your answer should be compact. 0.33. What is the ratio of the Debt(current US$) in Madagascar in 1976 to that in 1981?
Your answer should be compact. 0.03. What is the ratio of the Debt(current US$) of Mexico in 1976 to that in 1981?
Make the answer very short. 0.43. What is the ratio of the Debt(current US$) of Philippines in 1976 to that in 1981?
Give a very brief answer. 0.35. What is the ratio of the Debt(current US$) in Colombia in 1977 to that in 1978?
Provide a succinct answer. 0.5. What is the ratio of the Debt(current US$) in Madagascar in 1977 to that in 1978?
Give a very brief answer. 0.12. What is the ratio of the Debt(current US$) in Mexico in 1977 to that in 1978?
Ensure brevity in your answer.  0.88. What is the ratio of the Debt(current US$) of Philippines in 1977 to that in 1978?
Provide a short and direct response. 0.65. What is the ratio of the Debt(current US$) in Colombia in 1977 to that in 1979?
Offer a terse response. 0.4. What is the ratio of the Debt(current US$) of Madagascar in 1977 to that in 1979?
Provide a short and direct response. 0.1. What is the ratio of the Debt(current US$) in Mexico in 1977 to that in 1979?
Your answer should be very brief. 0.63. What is the ratio of the Debt(current US$) in Philippines in 1977 to that in 1979?
Give a very brief answer. 0.65. What is the ratio of the Debt(current US$) of Colombia in 1977 to that in 1980?
Ensure brevity in your answer.  0.2. What is the ratio of the Debt(current US$) of Madagascar in 1977 to that in 1980?
Offer a very short reply. 0.07. What is the ratio of the Debt(current US$) in Mexico in 1977 to that in 1980?
Provide a succinct answer. 1.58. What is the ratio of the Debt(current US$) of Philippines in 1977 to that in 1980?
Ensure brevity in your answer.  0.64. What is the ratio of the Debt(current US$) of Colombia in 1977 to that in 1981?
Give a very brief answer. 0.16. What is the ratio of the Debt(current US$) in Madagascar in 1977 to that in 1981?
Give a very brief answer. 0.09. What is the ratio of the Debt(current US$) of Mexico in 1977 to that in 1981?
Provide a short and direct response. 1.7. What is the ratio of the Debt(current US$) in Philippines in 1977 to that in 1981?
Provide a short and direct response. 0.45. What is the ratio of the Debt(current US$) of Colombia in 1978 to that in 1979?
Your answer should be very brief. 0.8. What is the ratio of the Debt(current US$) of Madagascar in 1978 to that in 1979?
Offer a terse response. 0.8. What is the ratio of the Debt(current US$) of Mexico in 1978 to that in 1979?
Provide a short and direct response. 0.72. What is the ratio of the Debt(current US$) of Colombia in 1978 to that in 1980?
Make the answer very short. 0.4. What is the ratio of the Debt(current US$) of Madagascar in 1978 to that in 1980?
Provide a short and direct response. 0.54. What is the ratio of the Debt(current US$) in Mexico in 1978 to that in 1980?
Your answer should be compact. 1.8. What is the ratio of the Debt(current US$) of Philippines in 1978 to that in 1980?
Keep it short and to the point. 0.98. What is the ratio of the Debt(current US$) of Colombia in 1978 to that in 1981?
Provide a short and direct response. 0.31. What is the ratio of the Debt(current US$) of Madagascar in 1978 to that in 1981?
Provide a short and direct response. 0.69. What is the ratio of the Debt(current US$) of Mexico in 1978 to that in 1981?
Ensure brevity in your answer.  1.94. What is the ratio of the Debt(current US$) in Philippines in 1978 to that in 1981?
Offer a terse response. 0.7. What is the ratio of the Debt(current US$) of Colombia in 1979 to that in 1980?
Provide a succinct answer. 0.5. What is the ratio of the Debt(current US$) of Madagascar in 1979 to that in 1980?
Offer a terse response. 0.68. What is the ratio of the Debt(current US$) in Mexico in 1979 to that in 1980?
Offer a terse response. 2.51. What is the ratio of the Debt(current US$) in Philippines in 1979 to that in 1980?
Provide a succinct answer. 0.98. What is the ratio of the Debt(current US$) in Colombia in 1979 to that in 1981?
Provide a short and direct response. 0.39. What is the ratio of the Debt(current US$) of Madagascar in 1979 to that in 1981?
Your answer should be very brief. 0.87. What is the ratio of the Debt(current US$) of Mexico in 1979 to that in 1981?
Provide a succinct answer. 2.71. What is the ratio of the Debt(current US$) of Philippines in 1979 to that in 1981?
Make the answer very short. 0.7. What is the ratio of the Debt(current US$) in Colombia in 1980 to that in 1981?
Offer a very short reply. 0.78. What is the ratio of the Debt(current US$) of Madagascar in 1980 to that in 1981?
Give a very brief answer. 1.27. What is the ratio of the Debt(current US$) of Mexico in 1980 to that in 1981?
Provide a short and direct response. 1.08. What is the ratio of the Debt(current US$) of Philippines in 1980 to that in 1981?
Provide a succinct answer. 0.71. What is the difference between the highest and the second highest Debt(current US$) in Colombia?
Provide a succinct answer. 1.86e+08. What is the difference between the highest and the second highest Debt(current US$) in Madagascar?
Your answer should be compact. 5.11e+07. What is the difference between the highest and the second highest Debt(current US$) in Mexico?
Your response must be concise. 1.31e+09. What is the difference between the highest and the second highest Debt(current US$) in Philippines?
Provide a short and direct response. 4.46e+08. What is the difference between the highest and the lowest Debt(current US$) of Colombia?
Offer a very short reply. 7.80e+08. What is the difference between the highest and the lowest Debt(current US$) in Madagascar?
Provide a succinct answer. 2.40e+08. What is the difference between the highest and the lowest Debt(current US$) of Mexico?
Your answer should be very brief. 4.37e+09. What is the difference between the highest and the lowest Debt(current US$) in Philippines?
Provide a short and direct response. 1.55e+09. 